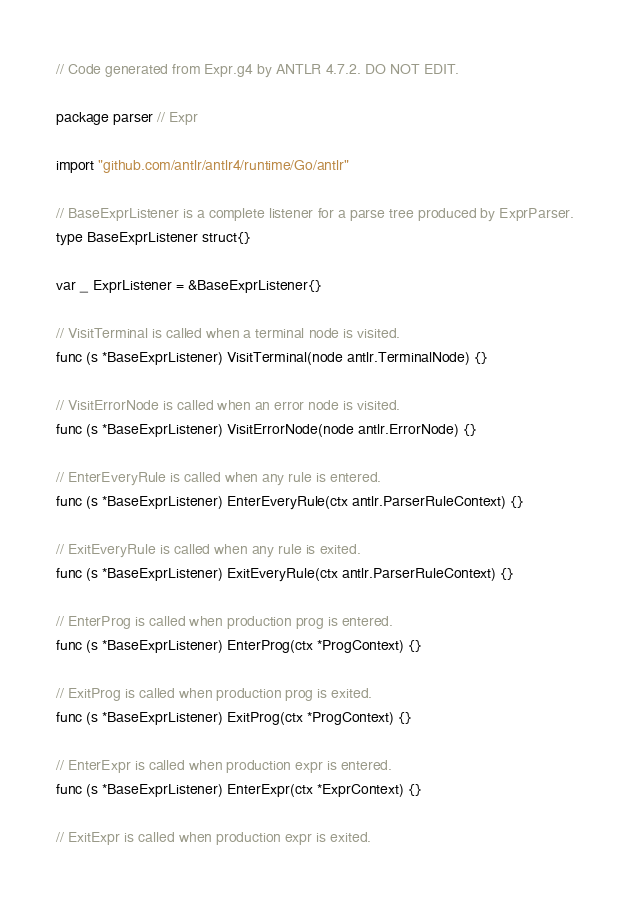Convert code to text. <code><loc_0><loc_0><loc_500><loc_500><_Go_>// Code generated from Expr.g4 by ANTLR 4.7.2. DO NOT EDIT.

package parser // Expr

import "github.com/antlr/antlr4/runtime/Go/antlr"

// BaseExprListener is a complete listener for a parse tree produced by ExprParser.
type BaseExprListener struct{}

var _ ExprListener = &BaseExprListener{}

// VisitTerminal is called when a terminal node is visited.
func (s *BaseExprListener) VisitTerminal(node antlr.TerminalNode) {}

// VisitErrorNode is called when an error node is visited.
func (s *BaseExprListener) VisitErrorNode(node antlr.ErrorNode) {}

// EnterEveryRule is called when any rule is entered.
func (s *BaseExprListener) EnterEveryRule(ctx antlr.ParserRuleContext) {}

// ExitEveryRule is called when any rule is exited.
func (s *BaseExprListener) ExitEveryRule(ctx antlr.ParserRuleContext) {}

// EnterProg is called when production prog is entered.
func (s *BaseExprListener) EnterProg(ctx *ProgContext) {}

// ExitProg is called when production prog is exited.
func (s *BaseExprListener) ExitProg(ctx *ProgContext) {}

// EnterExpr is called when production expr is entered.
func (s *BaseExprListener) EnterExpr(ctx *ExprContext) {}

// ExitExpr is called when production expr is exited.</code> 